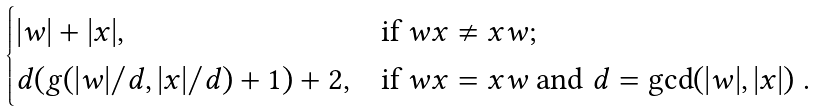<formula> <loc_0><loc_0><loc_500><loc_500>\begin{cases} | w | + | x | , & \text {if $wx \not= xw$} ; \\ d ( g ( | w | / d , | x | / d ) + 1 ) + 2 , & \text {if $wx = xw$ and $d = \gcd(|w|, |x|)$ } . \end{cases}</formula> 